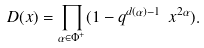<formula> <loc_0><loc_0><loc_500><loc_500>D ( { x } ) = \prod _ { \alpha \in \Phi ^ { + } } ( 1 - q ^ { d ( \alpha ) - 1 } \ x ^ { 2 \alpha } ) .</formula> 